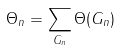<formula> <loc_0><loc_0><loc_500><loc_500>\Theta _ { n } = \sum _ { G _ { n } } \Theta ( G _ { n } )</formula> 